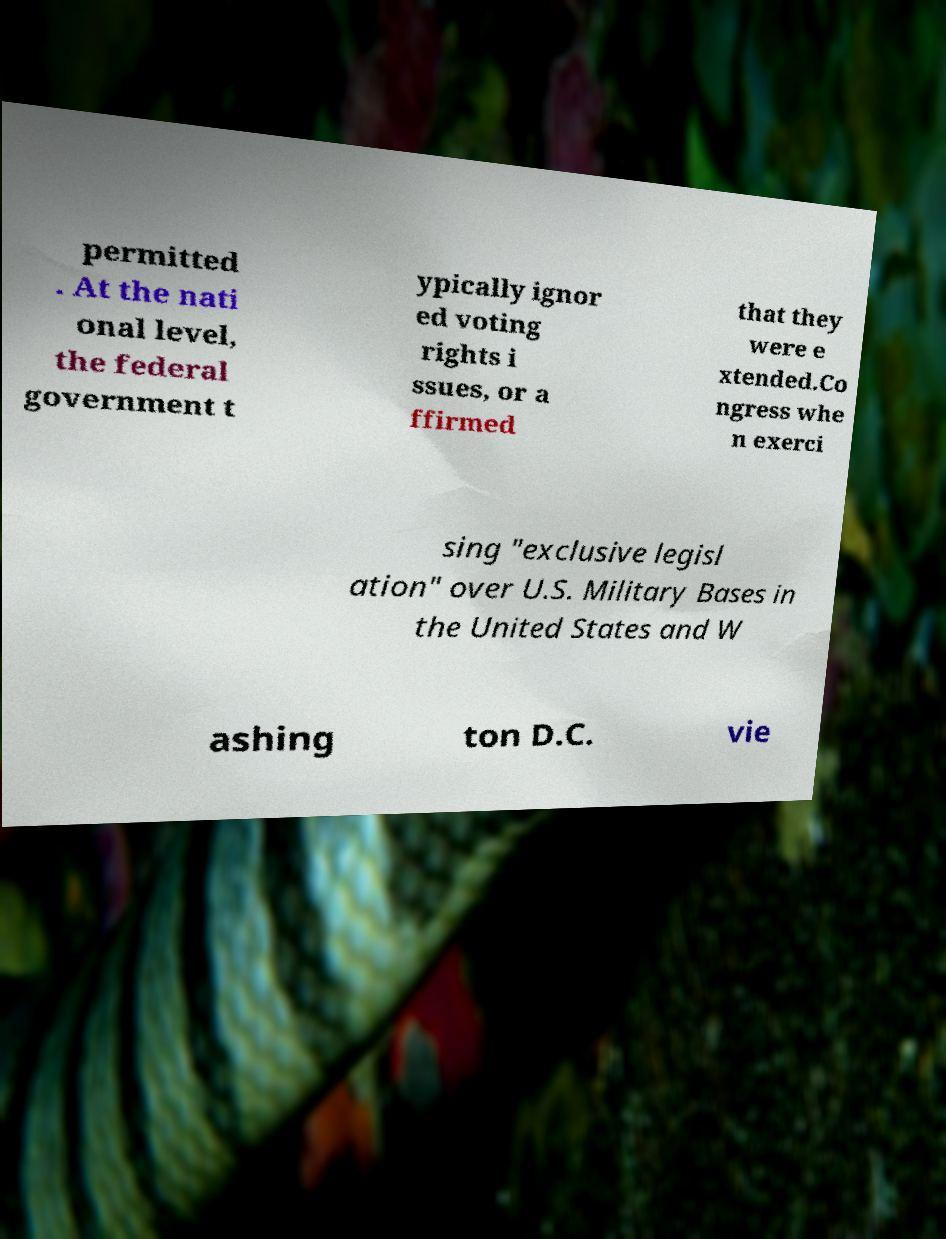For documentation purposes, I need the text within this image transcribed. Could you provide that? permitted . At the nati onal level, the federal government t ypically ignor ed voting rights i ssues, or a ffirmed that they were e xtended.Co ngress whe n exerci sing "exclusive legisl ation" over U.S. Military Bases in the United States and W ashing ton D.C. vie 